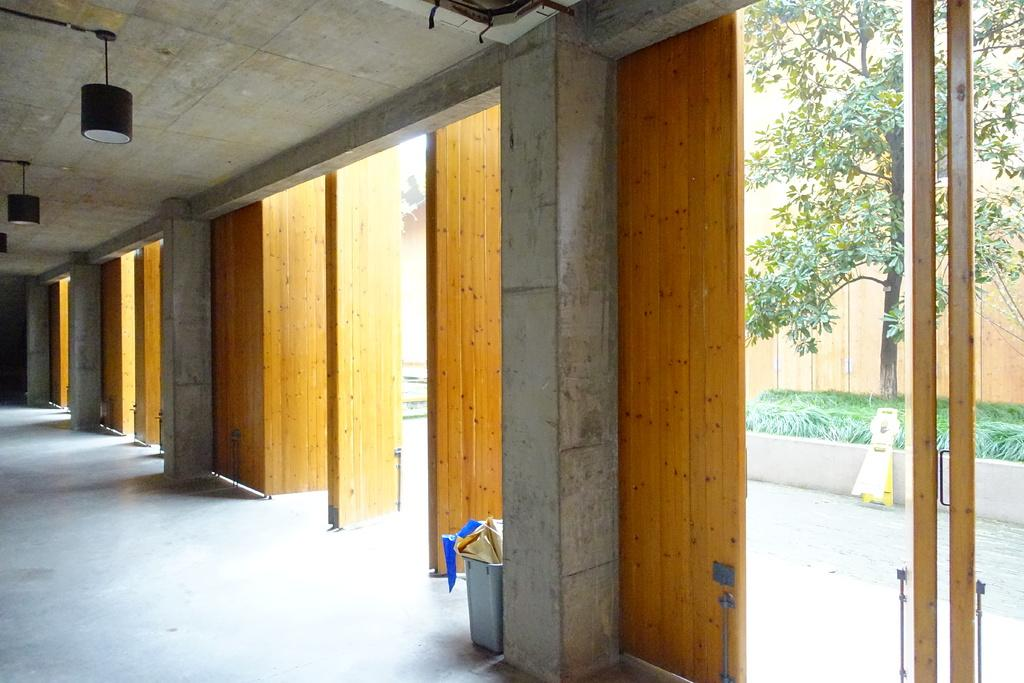What architectural features can be seen in the image? There are pillars in the image. What type of lighting is present in the image? There are lights on the ceiling in the image. What is on the floor in the image? There are objects on the floor in the image. What type of vegetation is present in the image? There is a tree and plants in the image. What type of barrier can be seen in the image? There is a wall in the image. What other objects can be seen on the ground in the image? There are other objects on the ground in the image. What type of vegetable is growing on the patch in the image? There is no patch or vegetable present in the image. How many trees are visible in the image? The image only shows one tree, not multiple trees. 